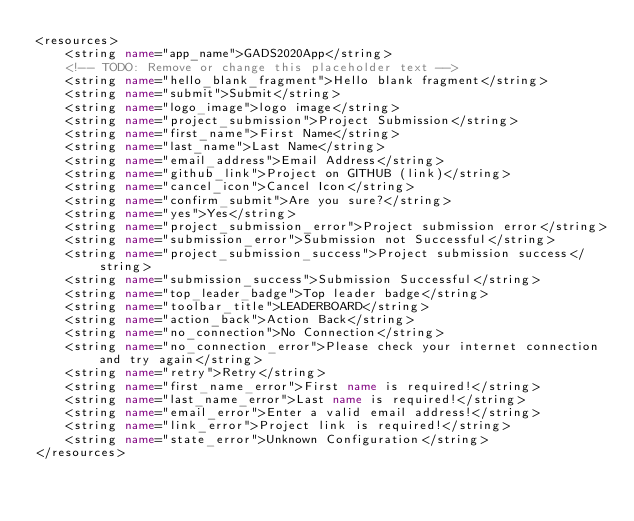Convert code to text. <code><loc_0><loc_0><loc_500><loc_500><_XML_><resources>
    <string name="app_name">GADS2020App</string>
    <!-- TODO: Remove or change this placeholder text -->
    <string name="hello_blank_fragment">Hello blank fragment</string>
    <string name="submit">Submit</string>
    <string name="logo_image">logo image</string>
    <string name="project_submission">Project Submission</string>
    <string name="first_name">First Name</string>
    <string name="last_name">Last Name</string>
    <string name="email_address">Email Address</string>
    <string name="github_link">Project on GITHUB (link)</string>
    <string name="cancel_icon">Cancel Icon</string>
    <string name="confirm_submit">Are you sure?</string>
    <string name="yes">Yes</string>
    <string name="project_submission_error">Project submission error</string>
    <string name="submission_error">Submission not Successful</string>
    <string name="project_submission_success">Project submission success</string>
    <string name="submission_success">Submission Successful</string>
    <string name="top_leader_badge">Top leader badge</string>
    <string name="toolbar_title">LEADERBOARD</string>
    <string name="action_back">Action Back</string>
    <string name="no_connection">No Connection</string>
    <string name="no_connection_error">Please check your internet connection and try again</string>
    <string name="retry">Retry</string>
    <string name="first_name_error">First name is required!</string>
    <string name="last_name_error">Last name is required!</string>
    <string name="email_error">Enter a valid email address!</string>
    <string name="link_error">Project link is required!</string>
    <string name="state_error">Unknown Configuration</string>
</resources></code> 